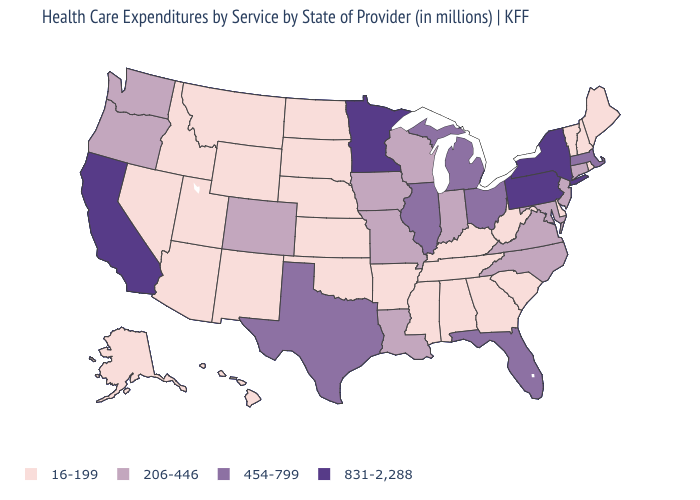Does Vermont have the lowest value in the Northeast?
Give a very brief answer. Yes. Which states hav the highest value in the MidWest?
Be succinct. Minnesota. What is the value of Wisconsin?
Be succinct. 206-446. Does Indiana have a higher value than North Dakota?
Quick response, please. Yes. Among the states that border Pennsylvania , which have the lowest value?
Give a very brief answer. Delaware, West Virginia. Among the states that border Delaware , which have the lowest value?
Write a very short answer. Maryland, New Jersey. What is the value of Arizona?
Concise answer only. 16-199. What is the highest value in the USA?
Quick response, please. 831-2,288. Name the states that have a value in the range 206-446?
Be succinct. Colorado, Connecticut, Indiana, Iowa, Louisiana, Maryland, Missouri, New Jersey, North Carolina, Oregon, Virginia, Washington, Wisconsin. What is the value of Arizona?
Quick response, please. 16-199. Does Illinois have the highest value in the MidWest?
Short answer required. No. What is the highest value in states that border North Dakota?
Concise answer only. 831-2,288. How many symbols are there in the legend?
Answer briefly. 4. Name the states that have a value in the range 16-199?
Concise answer only. Alabama, Alaska, Arizona, Arkansas, Delaware, Georgia, Hawaii, Idaho, Kansas, Kentucky, Maine, Mississippi, Montana, Nebraska, Nevada, New Hampshire, New Mexico, North Dakota, Oklahoma, Rhode Island, South Carolina, South Dakota, Tennessee, Utah, Vermont, West Virginia, Wyoming. Name the states that have a value in the range 16-199?
Answer briefly. Alabama, Alaska, Arizona, Arkansas, Delaware, Georgia, Hawaii, Idaho, Kansas, Kentucky, Maine, Mississippi, Montana, Nebraska, Nevada, New Hampshire, New Mexico, North Dakota, Oklahoma, Rhode Island, South Carolina, South Dakota, Tennessee, Utah, Vermont, West Virginia, Wyoming. 